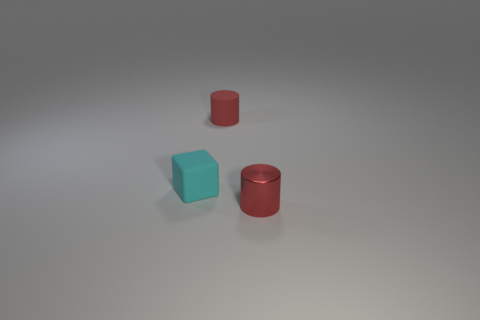Add 2 cyan things. How many objects exist? 5 Subtract all cylinders. How many objects are left? 1 Add 2 red cylinders. How many red cylinders are left? 4 Add 2 rubber things. How many rubber things exist? 4 Subtract 0 blue balls. How many objects are left? 3 Subtract all cyan blocks. Subtract all tiny metallic things. How many objects are left? 1 